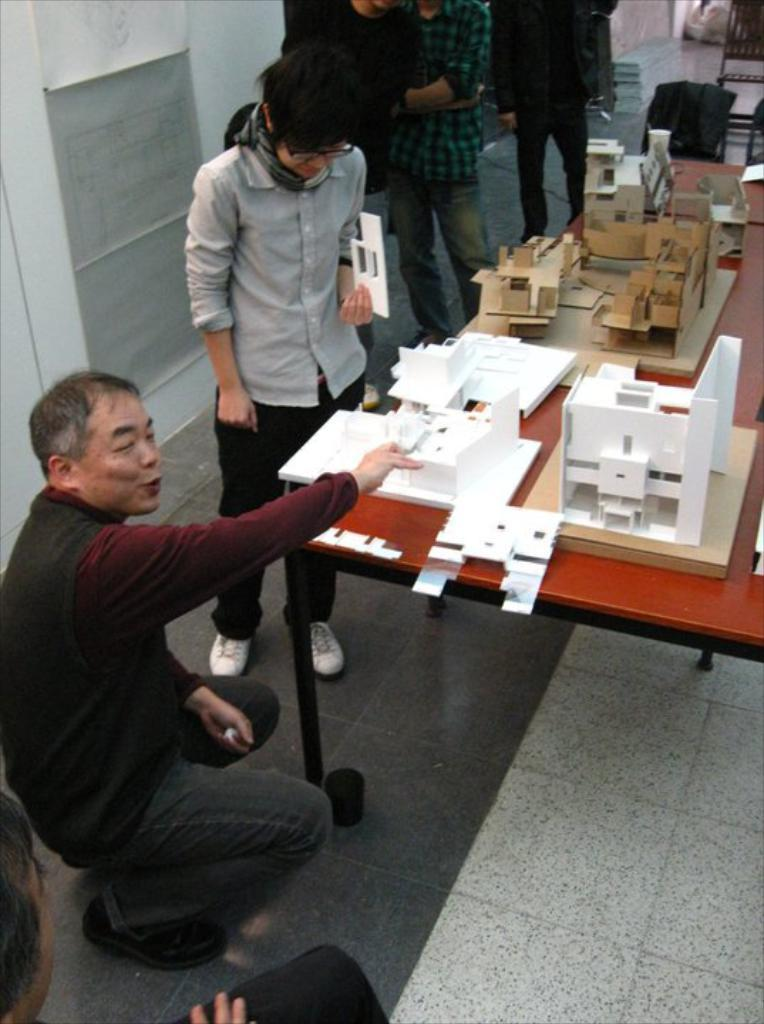How many people are in the image? There is a group of people in the image, but the exact number is not specified. What is the location of the group of people in the image? The group of people is in front of a table in the image. What is on the table in the image? There is a miniature on the table in the image. What can be seen in the background of the image? There are pipes attached to the wall in the background of the image. What type of silk is being used by the maid in the image? There is no maid or silk present in the image. Is the army visible in the image? There is no army or any military-related elements present in the image. 